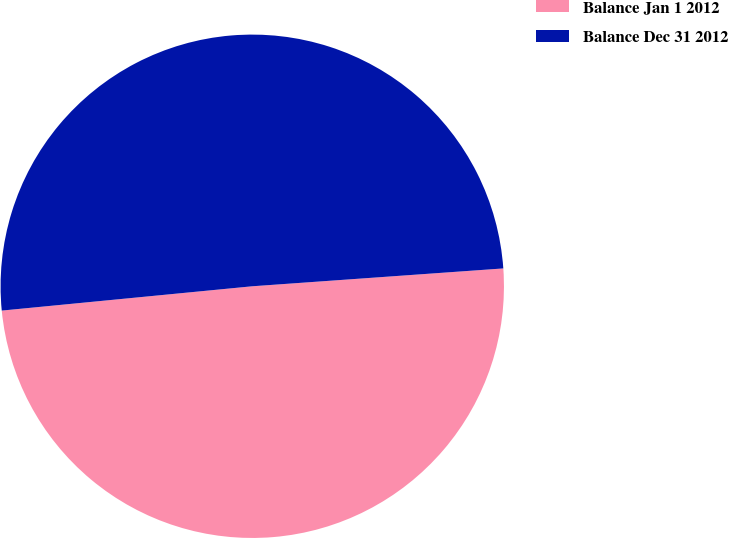Convert chart to OTSL. <chart><loc_0><loc_0><loc_500><loc_500><pie_chart><fcel>Balance Jan 1 2012<fcel>Balance Dec 31 2012<nl><fcel>49.59%<fcel>50.41%<nl></chart> 